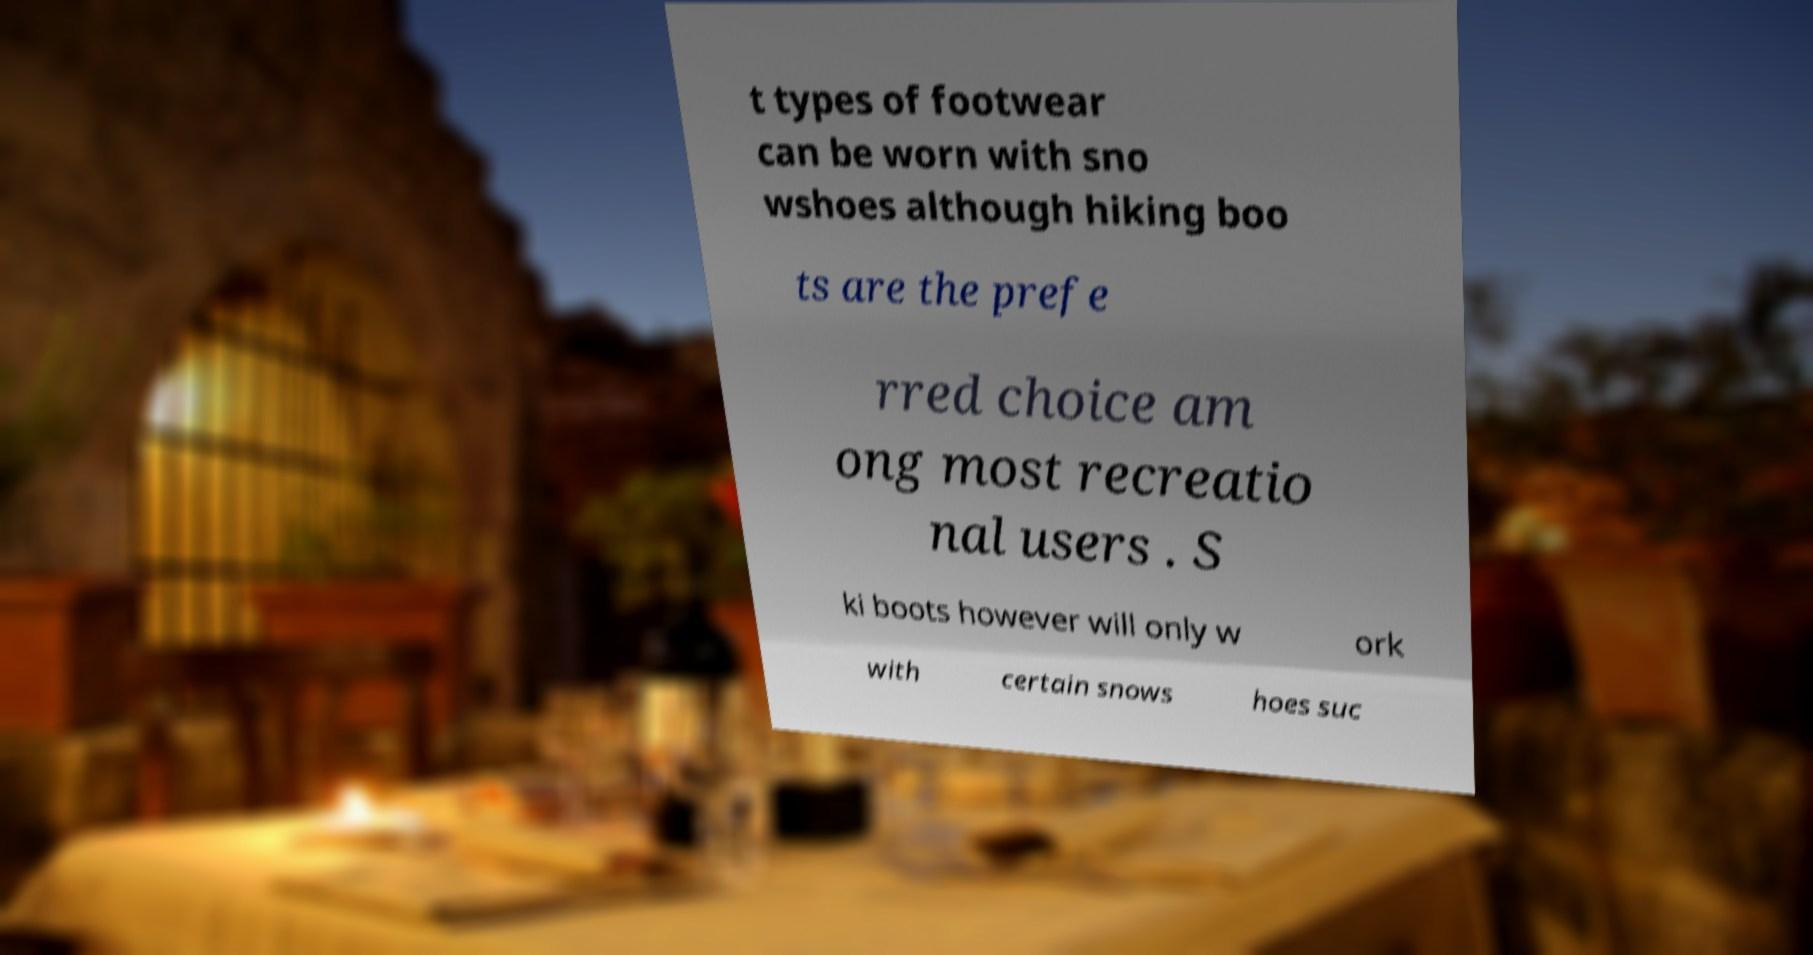Could you assist in decoding the text presented in this image and type it out clearly? t types of footwear can be worn with sno wshoes although hiking boo ts are the prefe rred choice am ong most recreatio nal users . S ki boots however will only w ork with certain snows hoes suc 